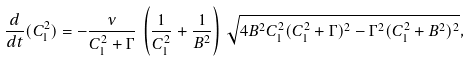Convert formula to latex. <formula><loc_0><loc_0><loc_500><loc_500>\frac { d } { d t } ( C _ { 1 } ^ { 2 } ) = - \frac { \nu } { C _ { 1 } ^ { 2 } + \Gamma } \, \left ( \frac { 1 } { C _ { 1 } ^ { 2 } } + \frac { 1 } { B ^ { 2 } } \right ) \, \sqrt { 4 B ^ { 2 } C _ { 1 } ^ { 2 } ( C _ { 1 } ^ { 2 } + \Gamma ) ^ { 2 } - \Gamma ^ { 2 } ( C _ { 1 } ^ { 2 } + B ^ { 2 } ) ^ { 2 } } ,</formula> 